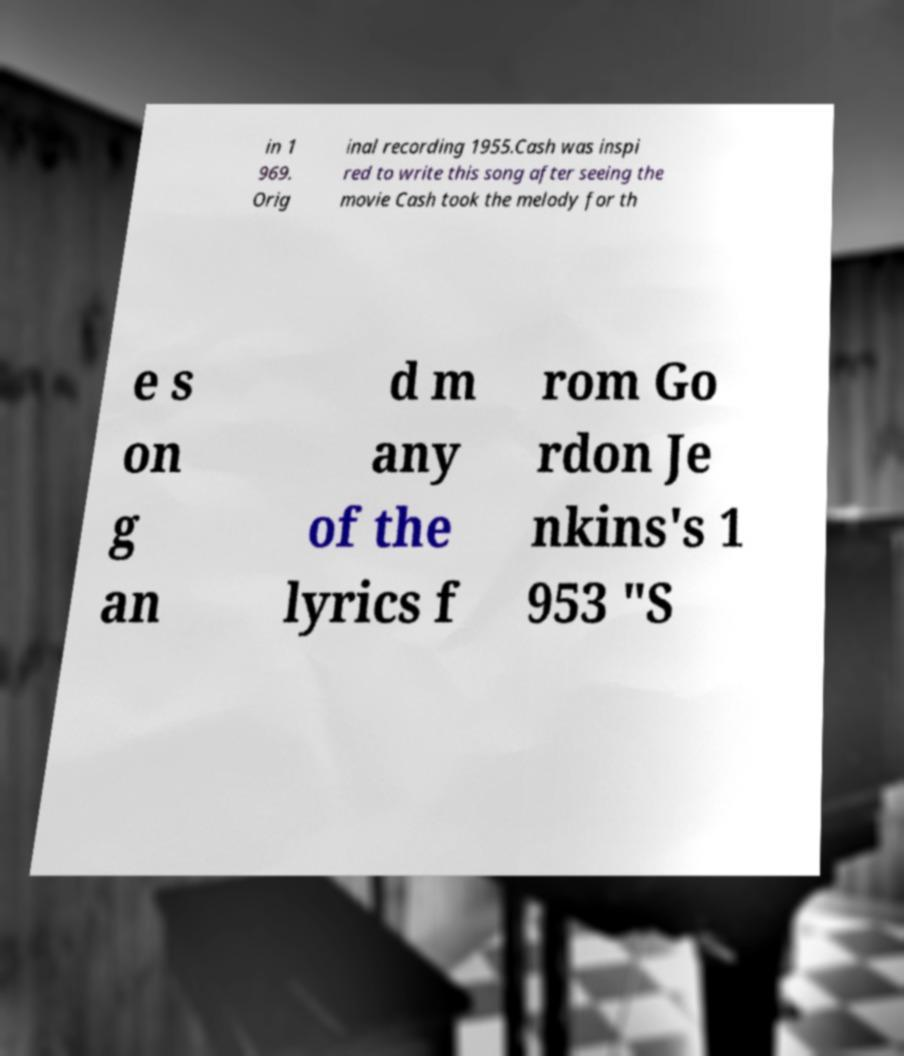Please identify and transcribe the text found in this image. in 1 969. Orig inal recording 1955.Cash was inspi red to write this song after seeing the movie Cash took the melody for th e s on g an d m any of the lyrics f rom Go rdon Je nkins's 1 953 "S 